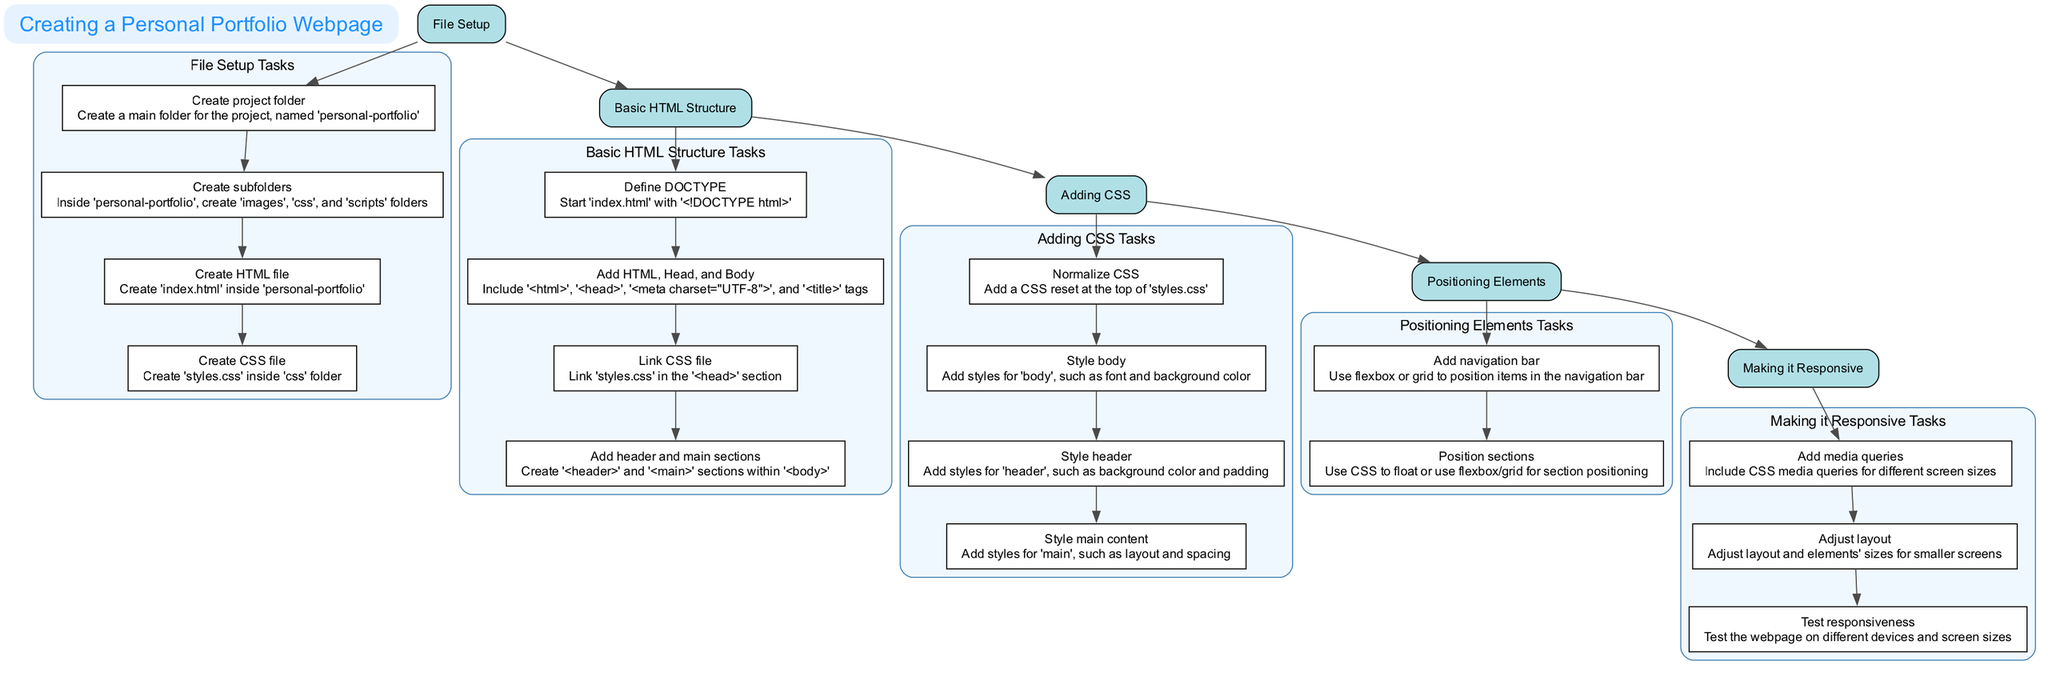What is the first step in creating a personal portfolio webpage? The first step listed in the diagram is "File Setup". This is indicated as the first node in the flow and serves as the starting point for the entire process.
Answer: File Setup How many tasks are included in the "Basic HTML Structure" step? The "Basic HTML Structure" step contains four tasks, as shown by the four associated nodes directly under this step in the diagram.
Answer: 4 What is the last task in the "Making it Responsive" step? The last task listed in the "Making it Responsive" step is "Test responsiveness". This is observed as the final node under this particular step in the diagram.
Answer: Test responsiveness Which task immediately follows "Style header" in the "Adding CSS" step? The task that follows "Style header" in the "Adding CSS" step is "Style main content". This is determined by the sequence in which the tasks are arranged below the "Adding CSS" step in the diagram.
Answer: Style main content What connects "Adding CSS" to "Positioning Elements"? The edge between "Adding CSS" and "Positioning Elements" signifies a connection as they are subsequent steps in the workflow. This connection indicates the order of execution in the process of creating a portfolio webpage.
Answer: An edge What type of layout style is suggested for arranging navigation items? The illustration suggests using "flexbox or grid" as the layout style for positioning items in the navigation bar, which corresponds to the task under "Positioning Elements".
Answer: Flexbox or grid How many total steps are in the diagram? According to the diagram, there are five distinct steps depicted, each corresponding to a different phase in the creation of a personal portfolio webpage.
Answer: 5 Which step involves "Add media queries"? The step that includes "Add media queries" is "Making it Responsive". This is indicated by the task listed under this specific step in the diagram.
Answer: Making it Responsive What is the primary goal of the "Making it Responsive" step? The primary goal of the "Making it Responsive" step is to ensure that the webpage looks good on all devices, as described in the purpose of this step in the diagram.
Answer: Ensure the webpage looks good on all devices 